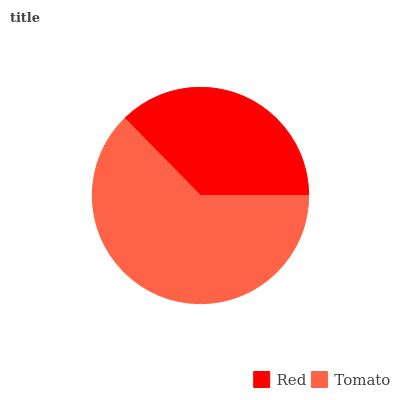Is Red the minimum?
Answer yes or no. Yes. Is Tomato the maximum?
Answer yes or no. Yes. Is Tomato the minimum?
Answer yes or no. No. Is Tomato greater than Red?
Answer yes or no. Yes. Is Red less than Tomato?
Answer yes or no. Yes. Is Red greater than Tomato?
Answer yes or no. No. Is Tomato less than Red?
Answer yes or no. No. Is Tomato the high median?
Answer yes or no. Yes. Is Red the low median?
Answer yes or no. Yes. Is Red the high median?
Answer yes or no. No. Is Tomato the low median?
Answer yes or no. No. 